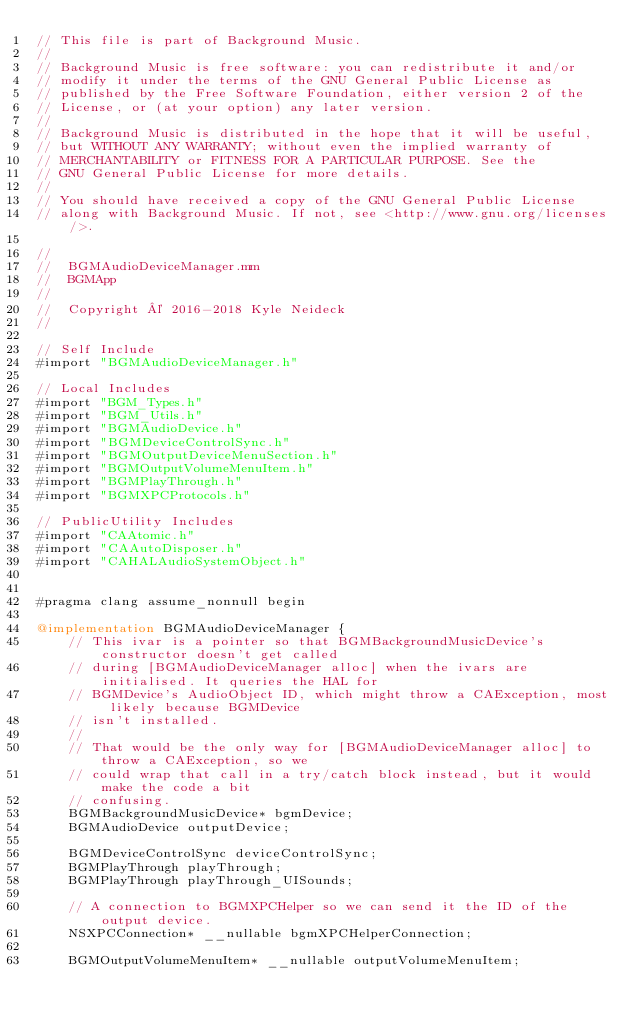Convert code to text. <code><loc_0><loc_0><loc_500><loc_500><_ObjectiveC_>// This file is part of Background Music.
//
// Background Music is free software: you can redistribute it and/or
// modify it under the terms of the GNU General Public License as
// published by the Free Software Foundation, either version 2 of the
// License, or (at your option) any later version.
//
// Background Music is distributed in the hope that it will be useful,
// but WITHOUT ANY WARRANTY; without even the implied warranty of
// MERCHANTABILITY or FITNESS FOR A PARTICULAR PURPOSE. See the
// GNU General Public License for more details.
//
// You should have received a copy of the GNU General Public License
// along with Background Music. If not, see <http://www.gnu.org/licenses/>.

//
//  BGMAudioDeviceManager.mm
//  BGMApp
//
//  Copyright © 2016-2018 Kyle Neideck
//

// Self Include
#import "BGMAudioDeviceManager.h"

// Local Includes
#import "BGM_Types.h"
#import "BGM_Utils.h"
#import "BGMAudioDevice.h"
#import "BGMDeviceControlSync.h"
#import "BGMOutputDeviceMenuSection.h"
#import "BGMOutputVolumeMenuItem.h"
#import "BGMPlayThrough.h"
#import "BGMXPCProtocols.h"

// PublicUtility Includes
#import "CAAtomic.h"
#import "CAAutoDisposer.h"
#import "CAHALAudioSystemObject.h"


#pragma clang assume_nonnull begin

@implementation BGMAudioDeviceManager {
    // This ivar is a pointer so that BGMBackgroundMusicDevice's constructor doesn't get called
    // during [BGMAudioDeviceManager alloc] when the ivars are initialised. It queries the HAL for
    // BGMDevice's AudioObject ID, which might throw a CAException, most likely because BGMDevice
    // isn't installed.
    //
    // That would be the only way for [BGMAudioDeviceManager alloc] to throw a CAException, so we
    // could wrap that call in a try/catch block instead, but it would make the code a bit
    // confusing.
    BGMBackgroundMusicDevice* bgmDevice;
    BGMAudioDevice outputDevice;
    
    BGMDeviceControlSync deviceControlSync;
    BGMPlayThrough playThrough;
    BGMPlayThrough playThrough_UISounds;

    // A connection to BGMXPCHelper so we can send it the ID of the output device.
    NSXPCConnection* __nullable bgmXPCHelperConnection;

    BGMOutputVolumeMenuItem* __nullable outputVolumeMenuItem;</code> 